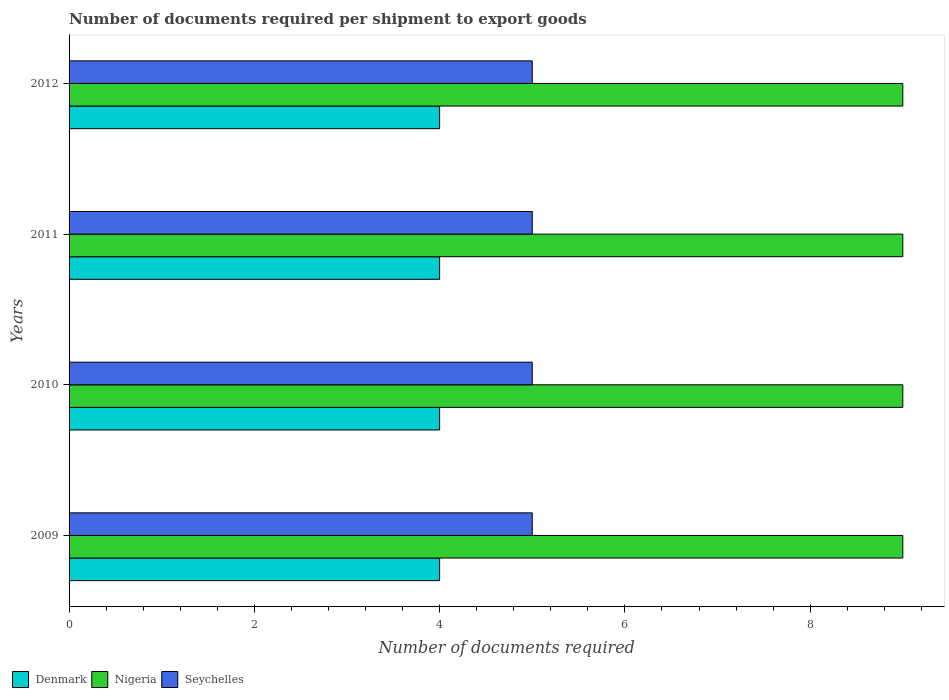How many different coloured bars are there?
Offer a terse response. 3. Are the number of bars on each tick of the Y-axis equal?
Make the answer very short. Yes. What is the label of the 3rd group of bars from the top?
Your answer should be compact. 2010. In how many cases, is the number of bars for a given year not equal to the number of legend labels?
Keep it short and to the point. 0. What is the number of documents required per shipment to export goods in Nigeria in 2010?
Keep it short and to the point. 9. Across all years, what is the maximum number of documents required per shipment to export goods in Seychelles?
Offer a terse response. 5. Across all years, what is the minimum number of documents required per shipment to export goods in Denmark?
Offer a very short reply. 4. In which year was the number of documents required per shipment to export goods in Seychelles maximum?
Offer a very short reply. 2009. In which year was the number of documents required per shipment to export goods in Denmark minimum?
Your answer should be compact. 2009. What is the total number of documents required per shipment to export goods in Denmark in the graph?
Ensure brevity in your answer.  16. What is the difference between the number of documents required per shipment to export goods in Nigeria in 2009 and that in 2012?
Your answer should be very brief. 0. What is the difference between the number of documents required per shipment to export goods in Seychelles in 2009 and the number of documents required per shipment to export goods in Nigeria in 2011?
Offer a terse response. -4. In the year 2010, what is the difference between the number of documents required per shipment to export goods in Seychelles and number of documents required per shipment to export goods in Denmark?
Your response must be concise. 1. What is the ratio of the number of documents required per shipment to export goods in Nigeria in 2009 to that in 2011?
Your answer should be compact. 1. Is the number of documents required per shipment to export goods in Nigeria in 2009 less than that in 2011?
Make the answer very short. No. In how many years, is the number of documents required per shipment to export goods in Denmark greater than the average number of documents required per shipment to export goods in Denmark taken over all years?
Provide a succinct answer. 0. Is the sum of the number of documents required per shipment to export goods in Denmark in 2009 and 2010 greater than the maximum number of documents required per shipment to export goods in Seychelles across all years?
Keep it short and to the point. Yes. What does the 2nd bar from the top in 2009 represents?
Offer a terse response. Nigeria. What does the 2nd bar from the bottom in 2011 represents?
Your answer should be compact. Nigeria. Is it the case that in every year, the sum of the number of documents required per shipment to export goods in Nigeria and number of documents required per shipment to export goods in Seychelles is greater than the number of documents required per shipment to export goods in Denmark?
Keep it short and to the point. Yes. How many bars are there?
Offer a terse response. 12. How many years are there in the graph?
Provide a succinct answer. 4. Are the values on the major ticks of X-axis written in scientific E-notation?
Ensure brevity in your answer.  No. What is the title of the graph?
Offer a terse response. Number of documents required per shipment to export goods. Does "Brunei Darussalam" appear as one of the legend labels in the graph?
Offer a very short reply. No. What is the label or title of the X-axis?
Provide a succinct answer. Number of documents required. What is the Number of documents required in Seychelles in 2009?
Your answer should be very brief. 5. What is the Number of documents required of Denmark in 2010?
Keep it short and to the point. 4. What is the Number of documents required of Nigeria in 2011?
Keep it short and to the point. 9. What is the Number of documents required of Seychelles in 2012?
Ensure brevity in your answer.  5. Across all years, what is the minimum Number of documents required of Denmark?
Give a very brief answer. 4. Across all years, what is the minimum Number of documents required in Nigeria?
Ensure brevity in your answer.  9. Across all years, what is the minimum Number of documents required in Seychelles?
Make the answer very short. 5. What is the total Number of documents required of Nigeria in the graph?
Your answer should be compact. 36. What is the difference between the Number of documents required in Denmark in 2009 and that in 2010?
Your answer should be compact. 0. What is the difference between the Number of documents required in Nigeria in 2009 and that in 2010?
Provide a succinct answer. 0. What is the difference between the Number of documents required of Seychelles in 2009 and that in 2010?
Offer a very short reply. 0. What is the difference between the Number of documents required in Nigeria in 2009 and that in 2011?
Provide a short and direct response. 0. What is the difference between the Number of documents required of Seychelles in 2009 and that in 2011?
Provide a short and direct response. 0. What is the difference between the Number of documents required of Denmark in 2009 and that in 2012?
Ensure brevity in your answer.  0. What is the difference between the Number of documents required of Nigeria in 2009 and that in 2012?
Keep it short and to the point. 0. What is the difference between the Number of documents required of Nigeria in 2010 and that in 2011?
Your answer should be very brief. 0. What is the difference between the Number of documents required of Seychelles in 2010 and that in 2011?
Ensure brevity in your answer.  0. What is the difference between the Number of documents required of Nigeria in 2010 and that in 2012?
Give a very brief answer. 0. What is the difference between the Number of documents required of Seychelles in 2010 and that in 2012?
Your answer should be very brief. 0. What is the difference between the Number of documents required in Denmark in 2011 and that in 2012?
Provide a short and direct response. 0. What is the difference between the Number of documents required in Nigeria in 2011 and that in 2012?
Your response must be concise. 0. What is the difference between the Number of documents required in Seychelles in 2011 and that in 2012?
Provide a succinct answer. 0. What is the difference between the Number of documents required in Denmark in 2009 and the Number of documents required in Nigeria in 2010?
Make the answer very short. -5. What is the difference between the Number of documents required in Denmark in 2009 and the Number of documents required in Seychelles in 2010?
Offer a terse response. -1. What is the difference between the Number of documents required of Nigeria in 2009 and the Number of documents required of Seychelles in 2010?
Your answer should be compact. 4. What is the difference between the Number of documents required in Denmark in 2009 and the Number of documents required in Nigeria in 2011?
Your answer should be compact. -5. What is the difference between the Number of documents required of Denmark in 2009 and the Number of documents required of Seychelles in 2012?
Offer a very short reply. -1. What is the difference between the Number of documents required of Nigeria in 2009 and the Number of documents required of Seychelles in 2012?
Offer a terse response. 4. What is the difference between the Number of documents required in Denmark in 2010 and the Number of documents required in Nigeria in 2011?
Ensure brevity in your answer.  -5. What is the difference between the Number of documents required of Denmark in 2010 and the Number of documents required of Seychelles in 2011?
Your response must be concise. -1. What is the difference between the Number of documents required of Nigeria in 2010 and the Number of documents required of Seychelles in 2011?
Ensure brevity in your answer.  4. What is the difference between the Number of documents required in Denmark in 2010 and the Number of documents required in Nigeria in 2012?
Your answer should be very brief. -5. What is the difference between the Number of documents required of Denmark in 2010 and the Number of documents required of Seychelles in 2012?
Ensure brevity in your answer.  -1. What is the difference between the Number of documents required in Nigeria in 2011 and the Number of documents required in Seychelles in 2012?
Offer a very short reply. 4. In the year 2009, what is the difference between the Number of documents required of Nigeria and Number of documents required of Seychelles?
Your answer should be very brief. 4. In the year 2010, what is the difference between the Number of documents required in Denmark and Number of documents required in Seychelles?
Offer a terse response. -1. In the year 2010, what is the difference between the Number of documents required in Nigeria and Number of documents required in Seychelles?
Provide a short and direct response. 4. In the year 2011, what is the difference between the Number of documents required in Nigeria and Number of documents required in Seychelles?
Offer a very short reply. 4. What is the ratio of the Number of documents required of Denmark in 2009 to that in 2010?
Provide a succinct answer. 1. What is the ratio of the Number of documents required in Nigeria in 2009 to that in 2010?
Give a very brief answer. 1. What is the ratio of the Number of documents required in Nigeria in 2009 to that in 2011?
Give a very brief answer. 1. What is the ratio of the Number of documents required in Denmark in 2009 to that in 2012?
Offer a terse response. 1. What is the ratio of the Number of documents required in Nigeria in 2009 to that in 2012?
Keep it short and to the point. 1. What is the ratio of the Number of documents required of Seychelles in 2009 to that in 2012?
Make the answer very short. 1. What is the ratio of the Number of documents required in Seychelles in 2010 to that in 2011?
Offer a terse response. 1. What is the ratio of the Number of documents required of Denmark in 2010 to that in 2012?
Provide a short and direct response. 1. What is the ratio of the Number of documents required in Nigeria in 2010 to that in 2012?
Make the answer very short. 1. What is the ratio of the Number of documents required in Seychelles in 2010 to that in 2012?
Offer a very short reply. 1. What is the ratio of the Number of documents required in Denmark in 2011 to that in 2012?
Your response must be concise. 1. What is the difference between the highest and the second highest Number of documents required of Denmark?
Give a very brief answer. 0. What is the difference between the highest and the second highest Number of documents required of Nigeria?
Ensure brevity in your answer.  0. What is the difference between the highest and the second highest Number of documents required in Seychelles?
Make the answer very short. 0. What is the difference between the highest and the lowest Number of documents required in Denmark?
Your answer should be compact. 0. What is the difference between the highest and the lowest Number of documents required of Nigeria?
Your response must be concise. 0. What is the difference between the highest and the lowest Number of documents required in Seychelles?
Make the answer very short. 0. 